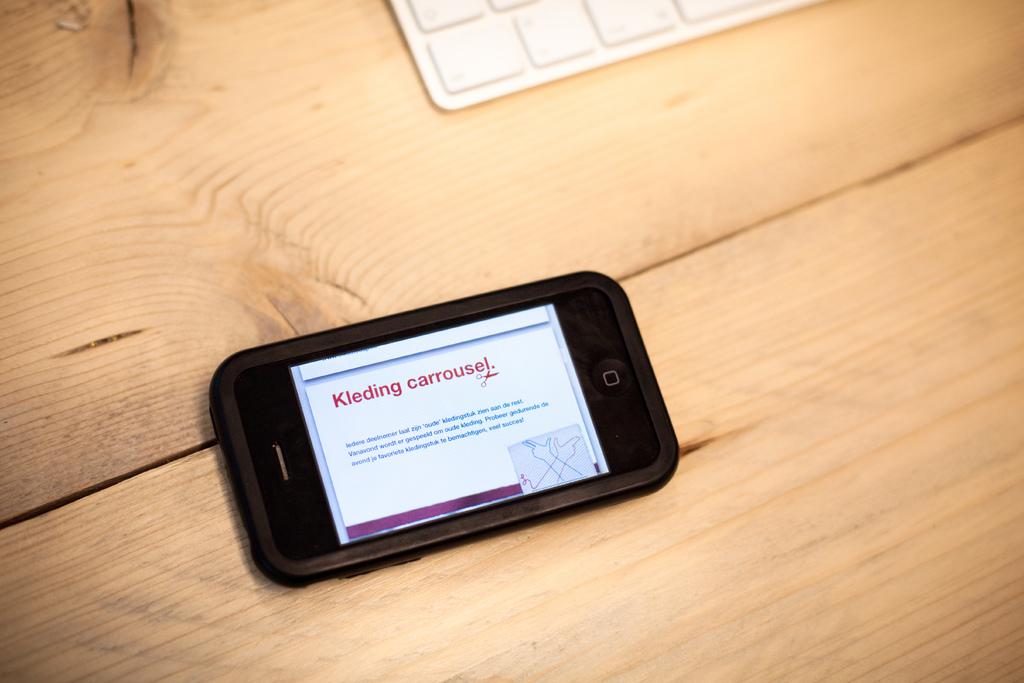What kind of carrousel is this?
Your response must be concise. Kleding. 